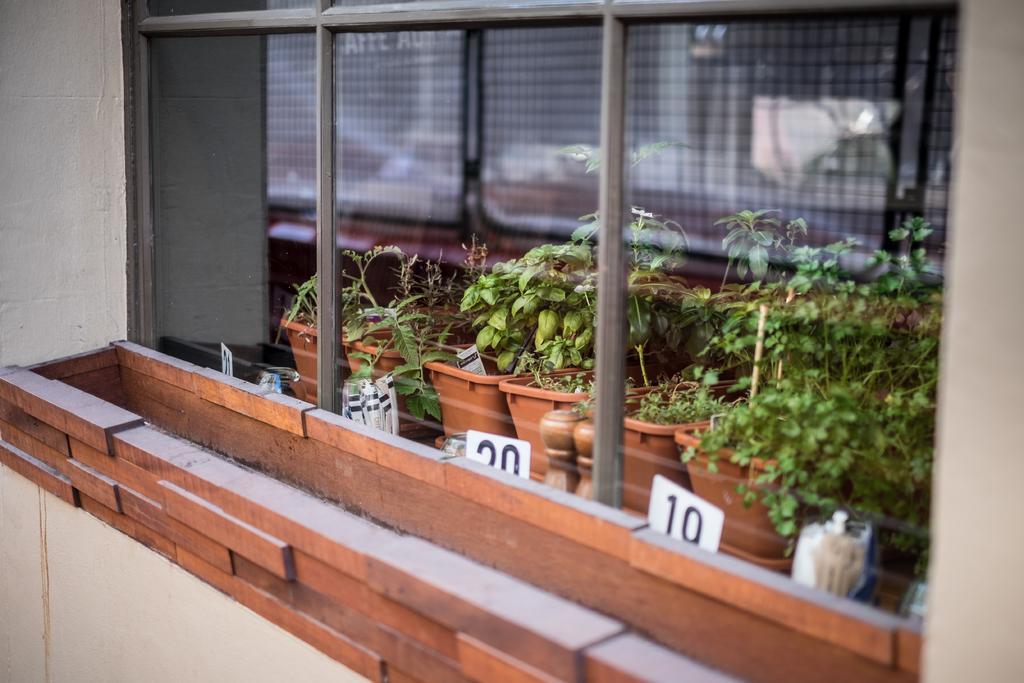Could you give a brief overview of what you see in this image? In this picture we can see few flower pots, plants and metal rods. 